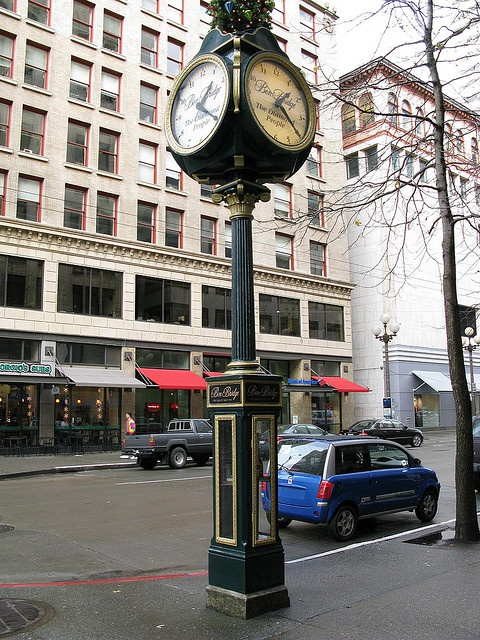Describe the objects in this image and their specific colors. I can see car in gray, black, blue, and navy tones, clock in gray, tan, olive, and black tones, clock in gray, white, darkgray, and beige tones, truck in gray, black, and darkgray tones, and car in gray, black, darkgray, and lightgray tones in this image. 